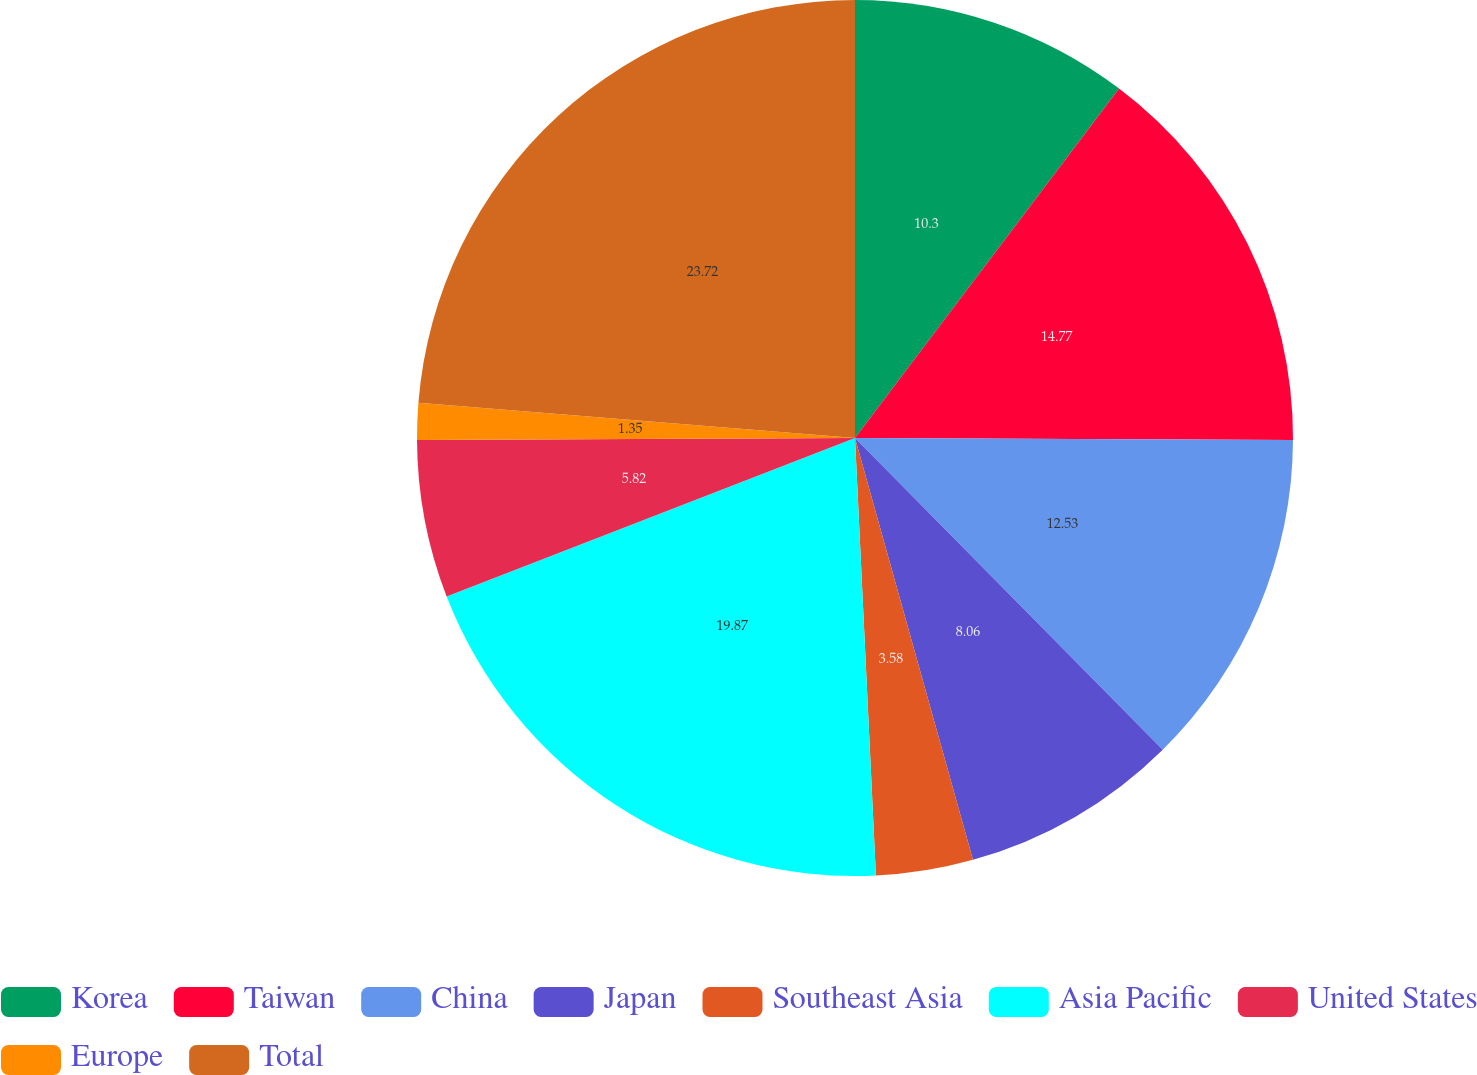Convert chart to OTSL. <chart><loc_0><loc_0><loc_500><loc_500><pie_chart><fcel>Korea<fcel>Taiwan<fcel>China<fcel>Japan<fcel>Southeast Asia<fcel>Asia Pacific<fcel>United States<fcel>Europe<fcel>Total<nl><fcel>10.3%<fcel>14.77%<fcel>12.53%<fcel>8.06%<fcel>3.58%<fcel>19.87%<fcel>5.82%<fcel>1.35%<fcel>23.72%<nl></chart> 